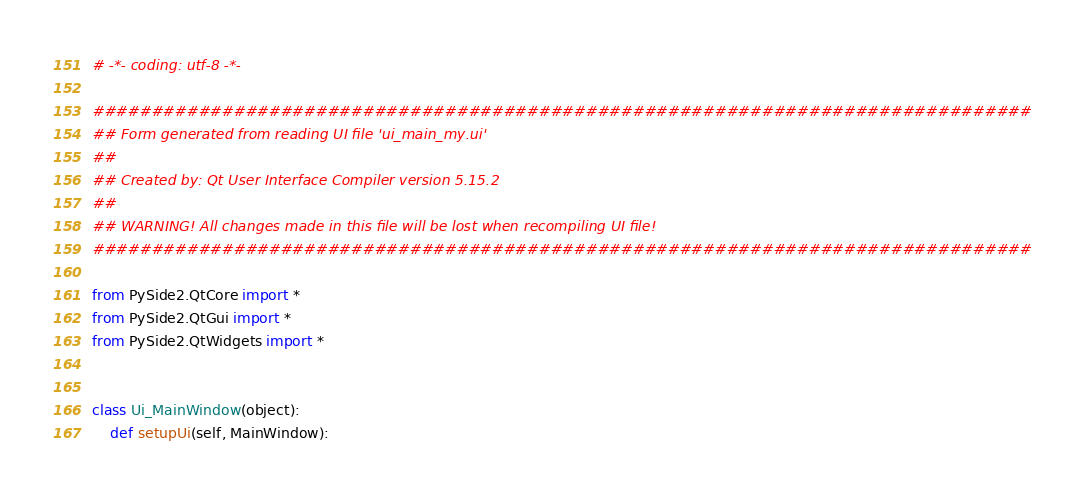<code> <loc_0><loc_0><loc_500><loc_500><_Python_># -*- coding: utf-8 -*-

################################################################################
## Form generated from reading UI file 'ui_main_my.ui'
##
## Created by: Qt User Interface Compiler version 5.15.2
##
## WARNING! All changes made in this file will be lost when recompiling UI file!
################################################################################

from PySide2.QtCore import *
from PySide2.QtGui import *
from PySide2.QtWidgets import *


class Ui_MainWindow(object):
    def setupUi(self, MainWindow):</code> 